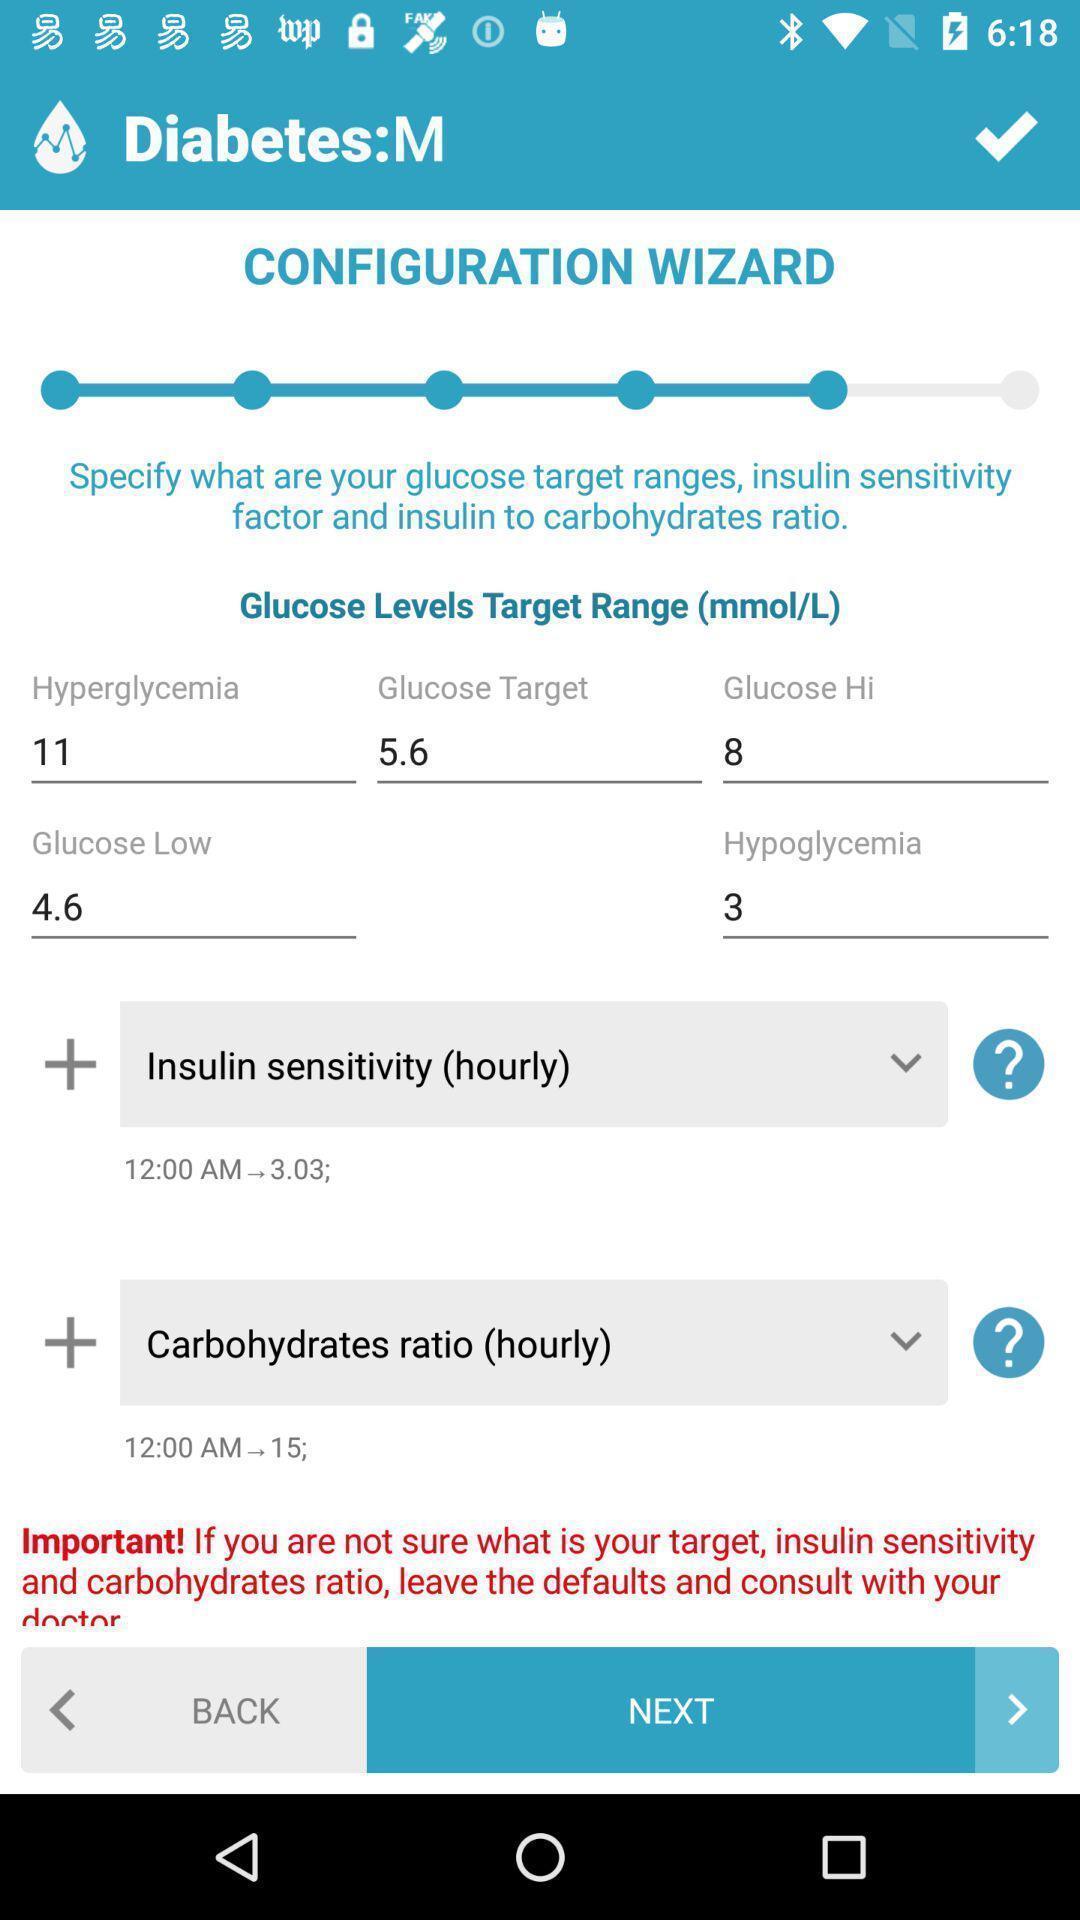What can you discern from this picture? Screen displaying the page of a medical app. 